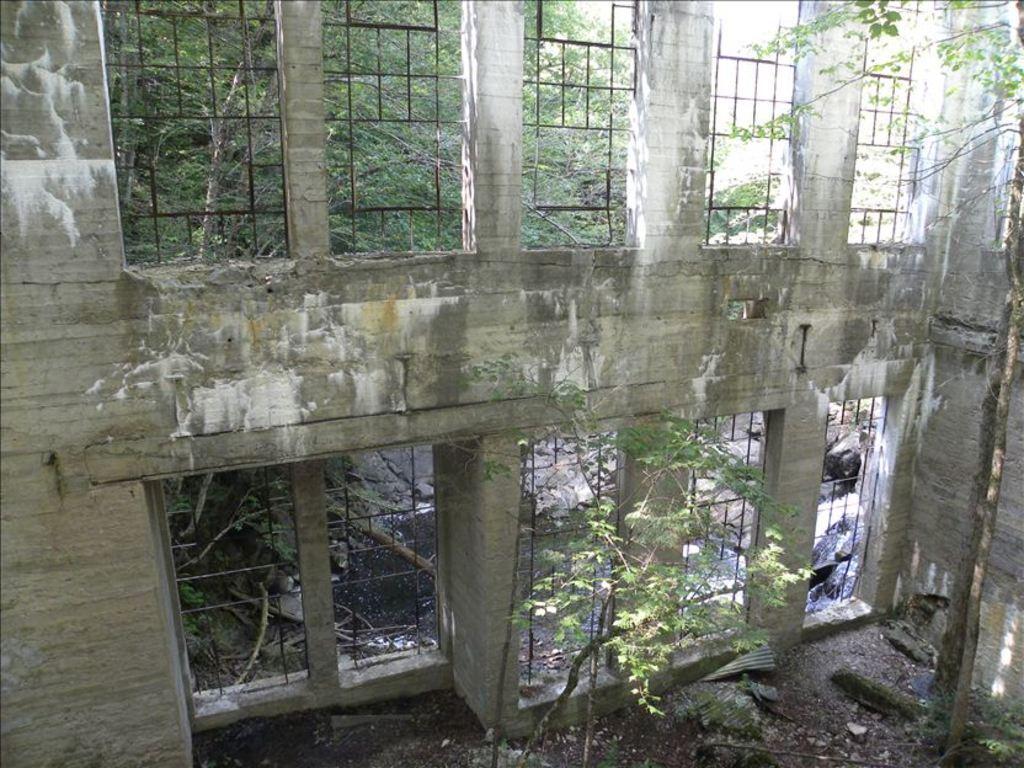How would you summarize this image in a sentence or two? In this image we can see a wall with iron rods and in the background there are trees. 